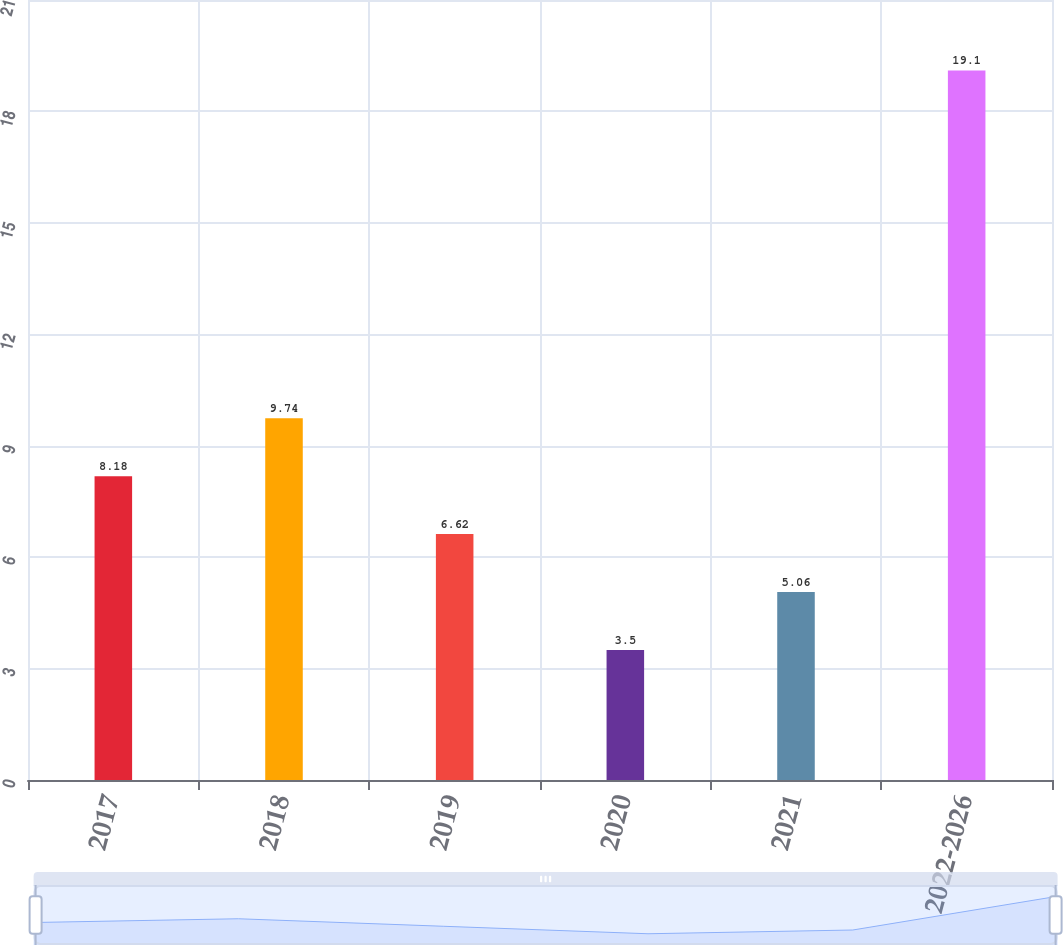Convert chart to OTSL. <chart><loc_0><loc_0><loc_500><loc_500><bar_chart><fcel>2017<fcel>2018<fcel>2019<fcel>2020<fcel>2021<fcel>2022-2026<nl><fcel>8.18<fcel>9.74<fcel>6.62<fcel>3.5<fcel>5.06<fcel>19.1<nl></chart> 